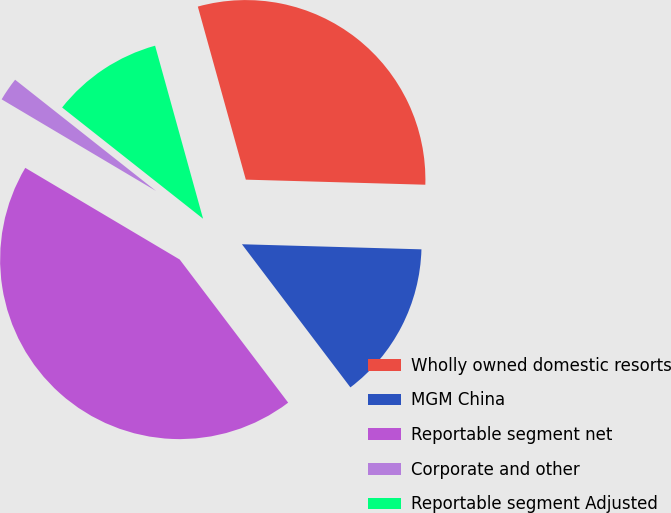Convert chart to OTSL. <chart><loc_0><loc_0><loc_500><loc_500><pie_chart><fcel>Wholly owned domestic resorts<fcel>MGM China<fcel>Reportable segment net<fcel>Corporate and other<fcel>Reportable segment Adjusted<nl><fcel>29.76%<fcel>14.23%<fcel>43.85%<fcel>2.11%<fcel>10.06%<nl></chart> 